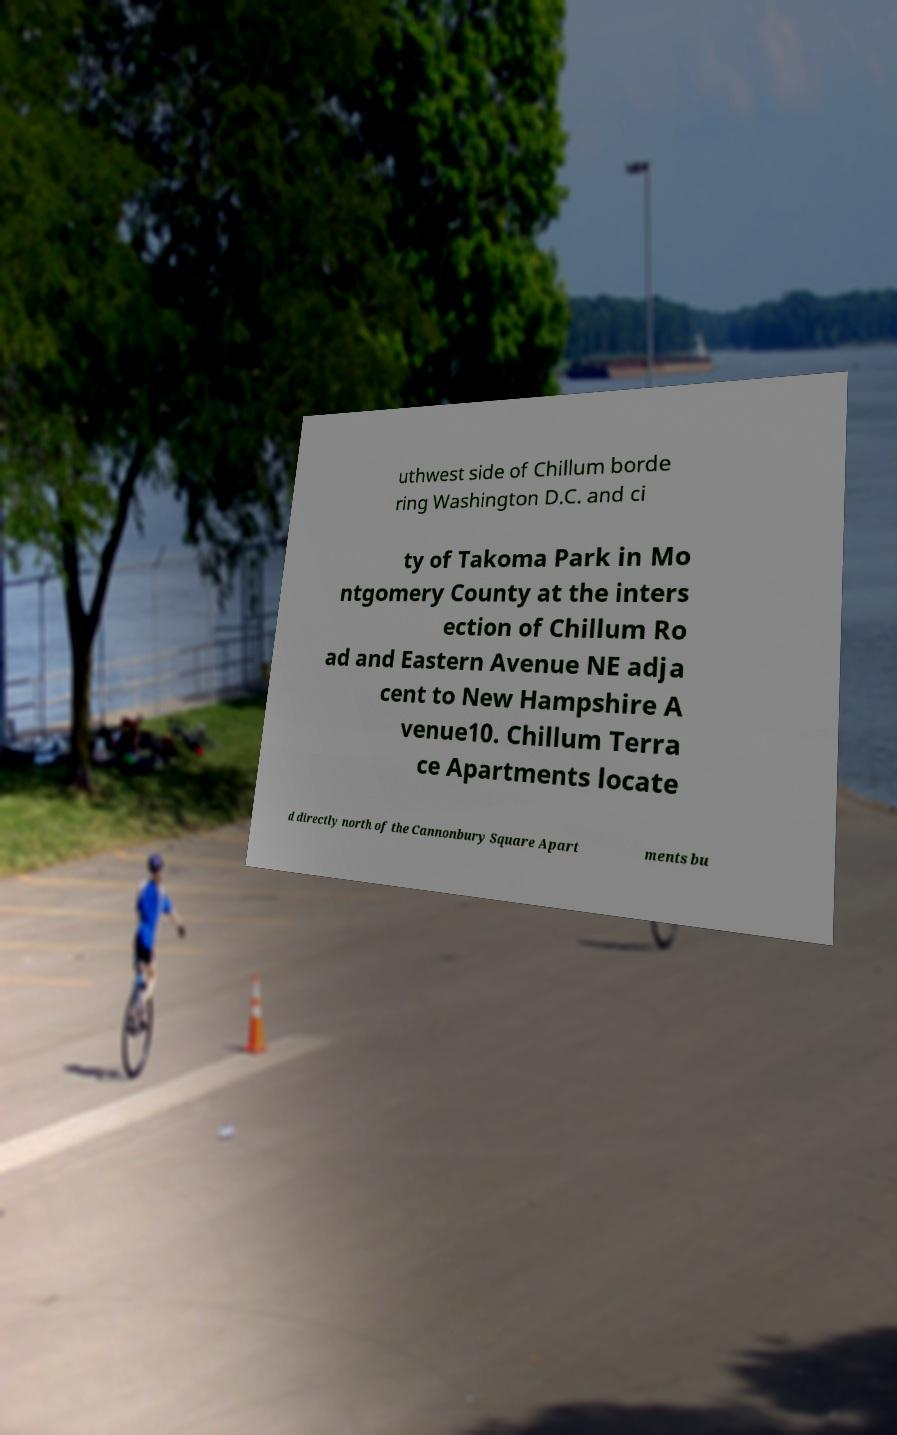For documentation purposes, I need the text within this image transcribed. Could you provide that? uthwest side of Chillum borde ring Washington D.C. and ci ty of Takoma Park in Mo ntgomery County at the inters ection of Chillum Ro ad and Eastern Avenue NE adja cent to New Hampshire A venue10. Chillum Terra ce Apartments locate d directly north of the Cannonbury Square Apart ments bu 